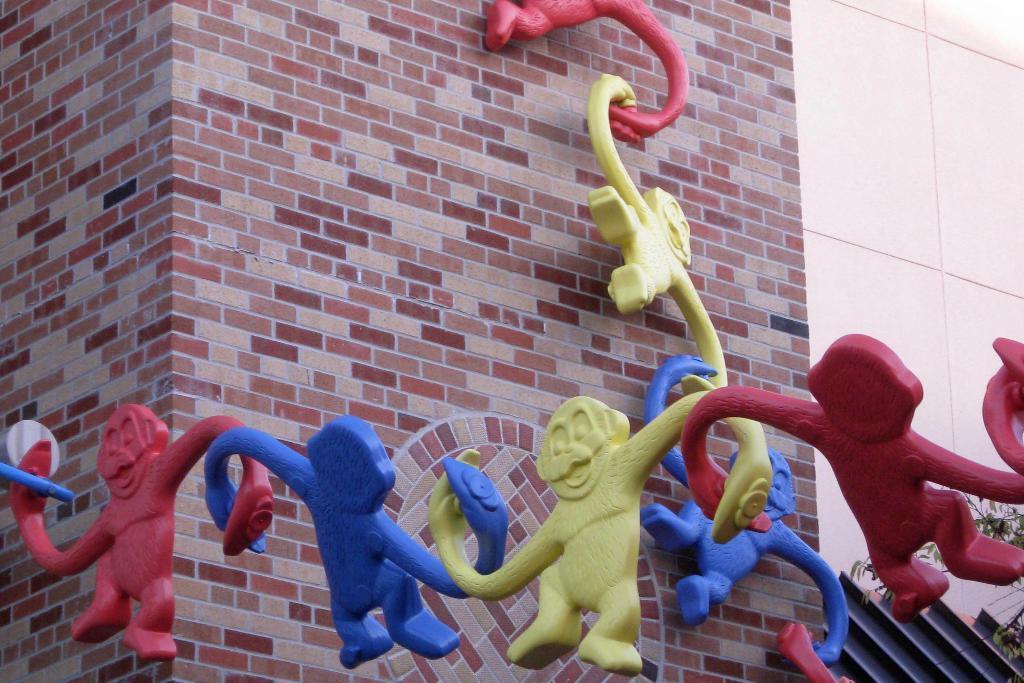How would you summarize this image in a sentence or two? In this picture we observe monkey sculptures of red,blue and green color. In the background there is a brick wall. 